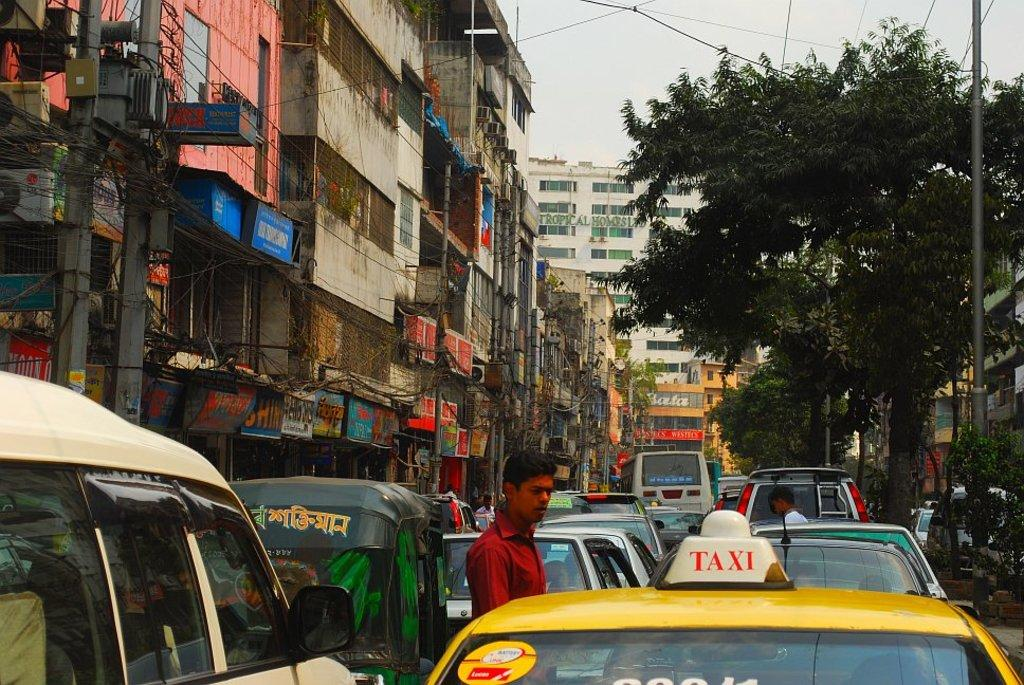<image>
Give a short and clear explanation of the subsequent image. Taxi stuck in traffic driving through city traffic. 